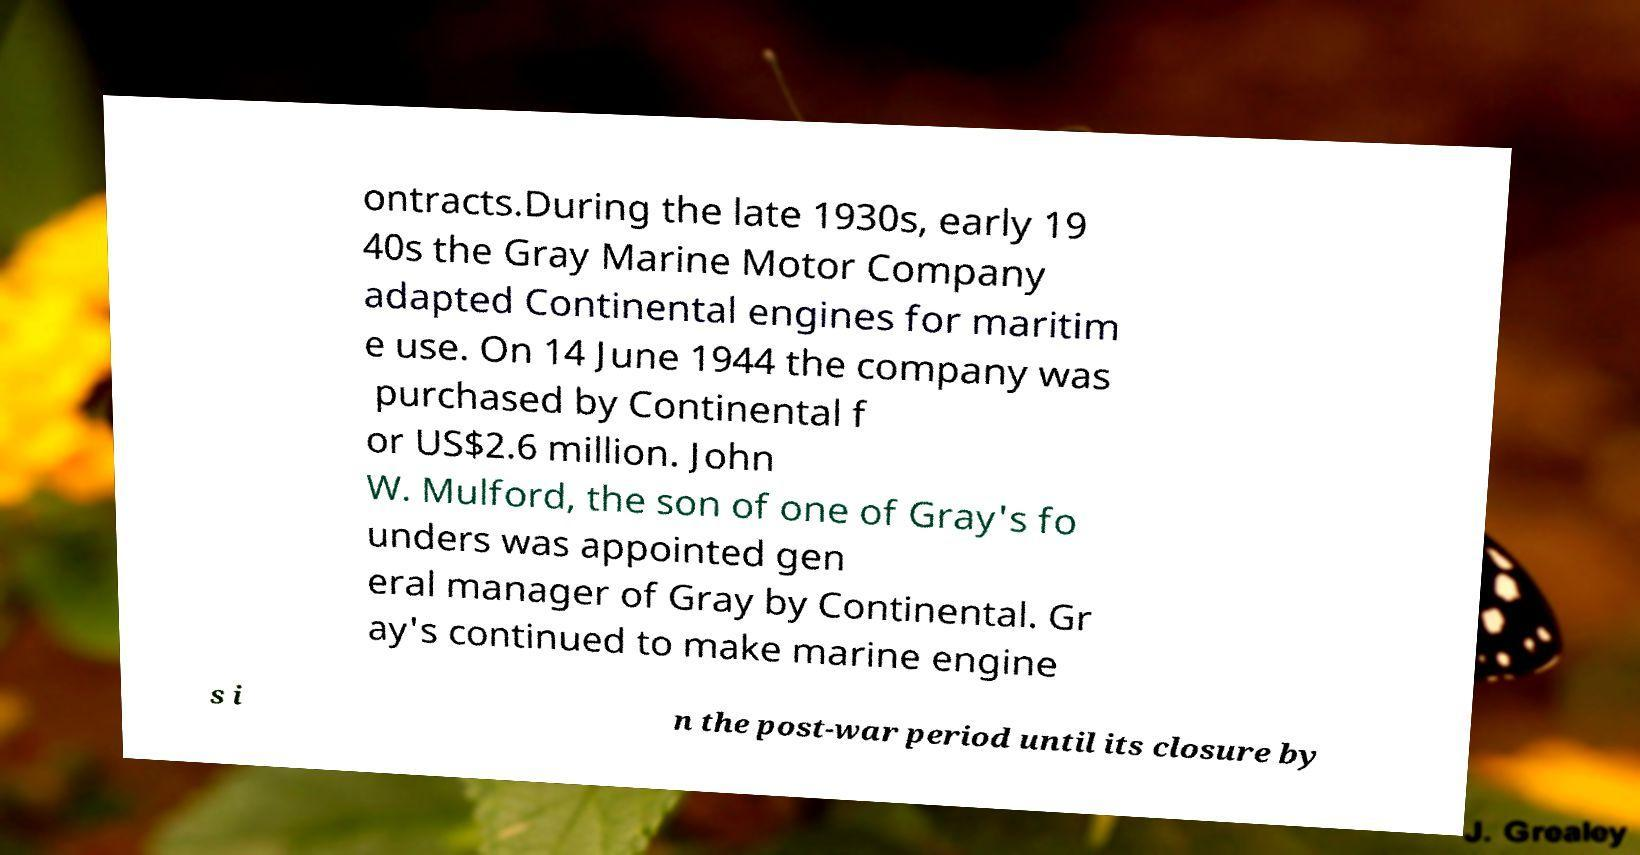Could you extract and type out the text from this image? ontracts.During the late 1930s, early 19 40s the Gray Marine Motor Company adapted Continental engines for maritim e use. On 14 June 1944 the company was purchased by Continental f or US$2.6 million. John W. Mulford, the son of one of Gray's fo unders was appointed gen eral manager of Gray by Continental. Gr ay's continued to make marine engine s i n the post-war period until its closure by 